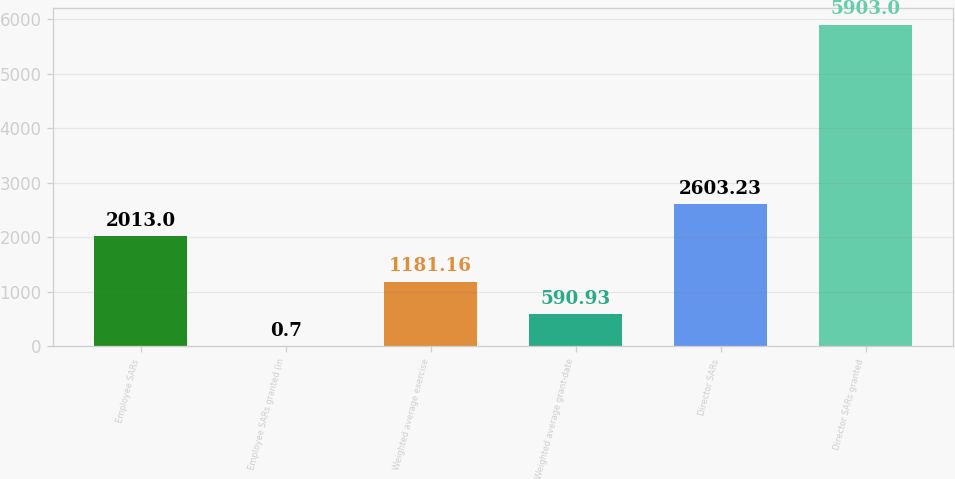Convert chart. <chart><loc_0><loc_0><loc_500><loc_500><bar_chart><fcel>Employee SARs<fcel>Employee SARs granted (in<fcel>Weighted average exercise<fcel>Weighted average grant-date<fcel>Director SARs<fcel>Director SARs granted<nl><fcel>2013<fcel>0.7<fcel>1181.16<fcel>590.93<fcel>2603.23<fcel>5903<nl></chart> 